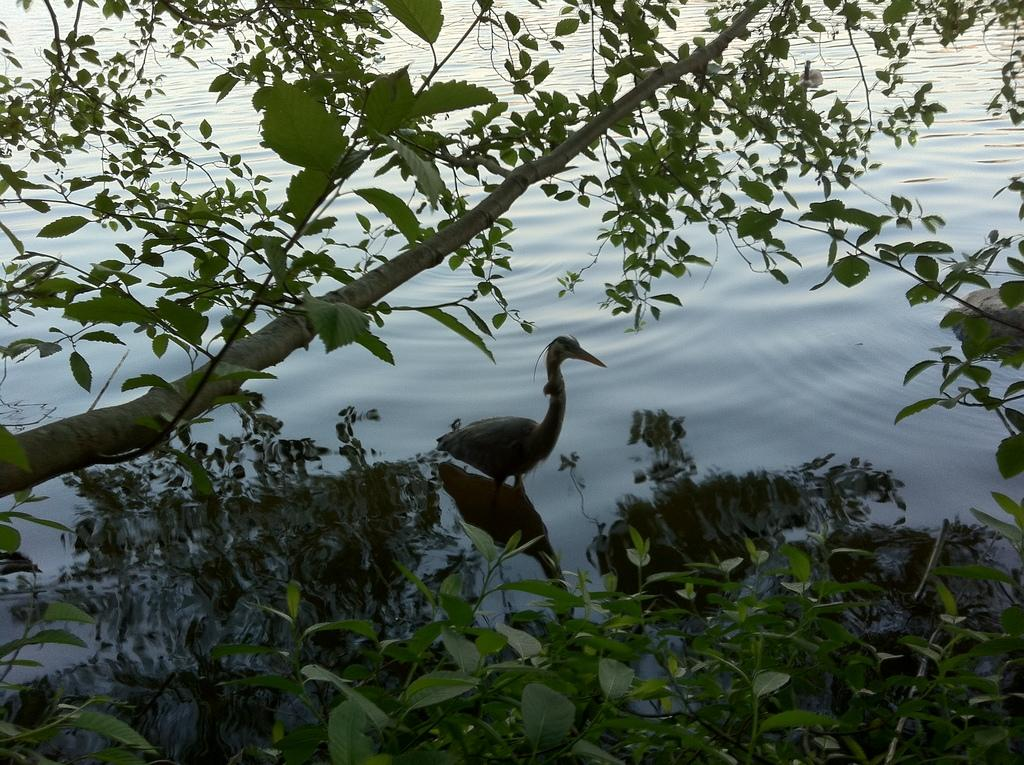What is located at the bottom of the image? There are plants at the bottom of the image. What can be seen in the center of the image? There is a bird in the water and a stem with branches and leaves in the center of the image. Can you tell me how many stamps are on the bird in the image? There are no stamps present on the bird in the image; it is a bird in the water with plants and a stem with branches and leaves. What type of worm can be seen crawling on the plants at the bottom of the image? There are no worms present on the plants at the bottom of the image; only plants are visible. 